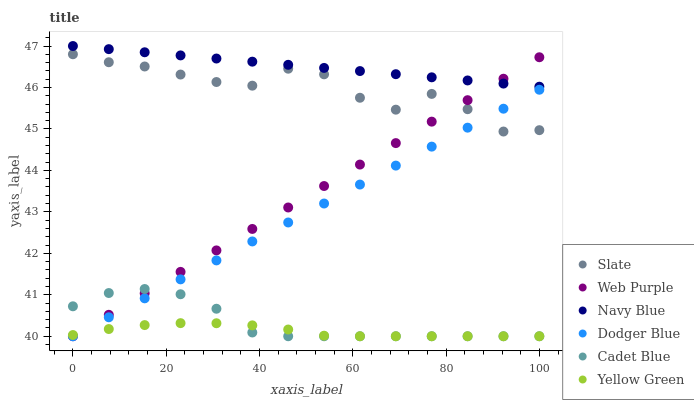Does Yellow Green have the minimum area under the curve?
Answer yes or no. Yes. Does Navy Blue have the maximum area under the curve?
Answer yes or no. Yes. Does Navy Blue have the minimum area under the curve?
Answer yes or no. No. Does Yellow Green have the maximum area under the curve?
Answer yes or no. No. Is Dodger Blue the smoothest?
Answer yes or no. Yes. Is Slate the roughest?
Answer yes or no. Yes. Is Yellow Green the smoothest?
Answer yes or no. No. Is Yellow Green the roughest?
Answer yes or no. No. Does Cadet Blue have the lowest value?
Answer yes or no. Yes. Does Navy Blue have the lowest value?
Answer yes or no. No. Does Navy Blue have the highest value?
Answer yes or no. Yes. Does Yellow Green have the highest value?
Answer yes or no. No. Is Yellow Green less than Navy Blue?
Answer yes or no. Yes. Is Navy Blue greater than Slate?
Answer yes or no. Yes. Does Yellow Green intersect Web Purple?
Answer yes or no. Yes. Is Yellow Green less than Web Purple?
Answer yes or no. No. Is Yellow Green greater than Web Purple?
Answer yes or no. No. Does Yellow Green intersect Navy Blue?
Answer yes or no. No. 